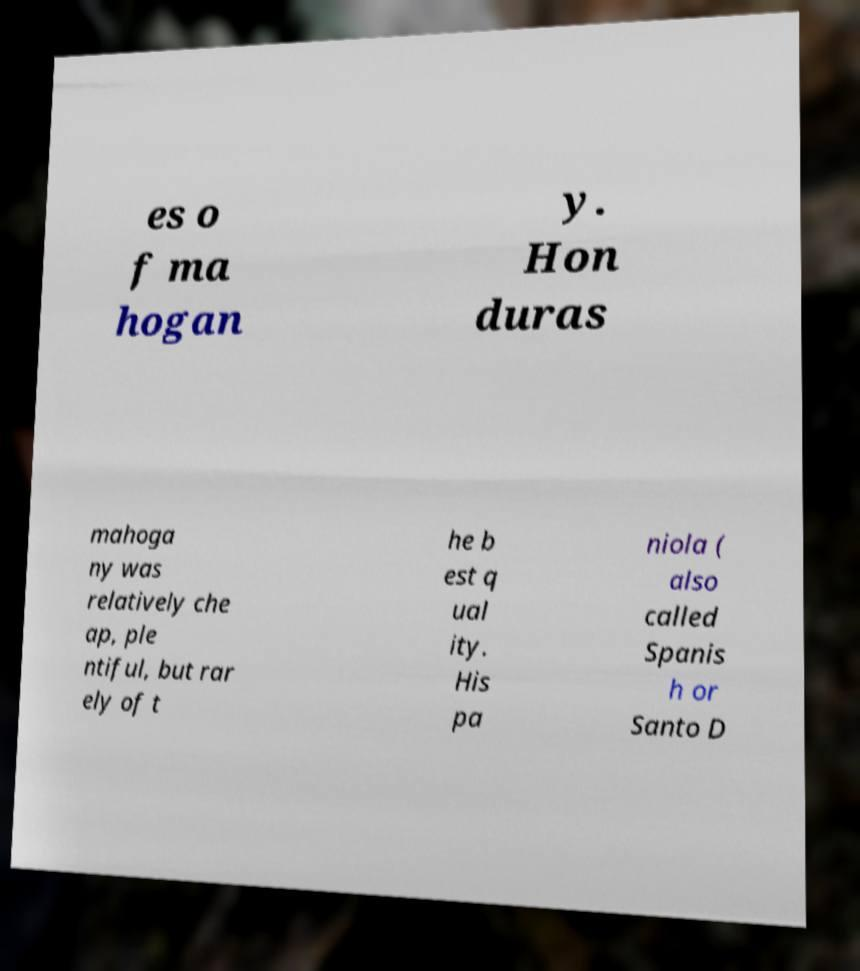Please read and relay the text visible in this image. What does it say? es o f ma hogan y. Hon duras mahoga ny was relatively che ap, ple ntiful, but rar ely of t he b est q ual ity. His pa niola ( also called Spanis h or Santo D 